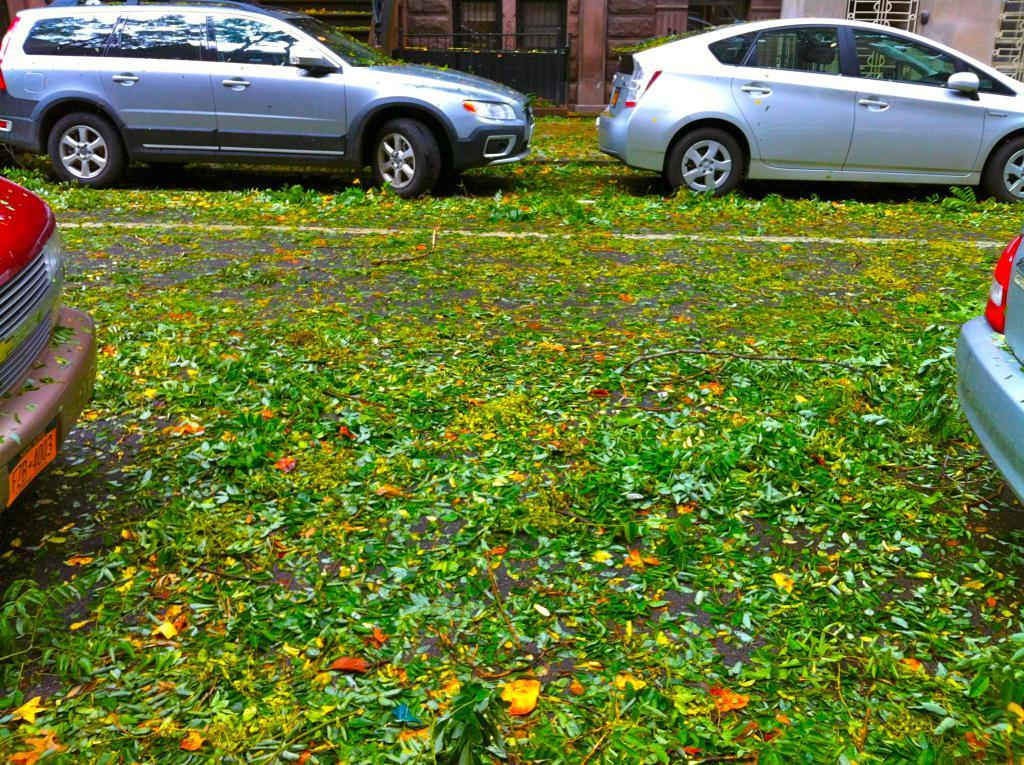What type of natural elements can be seen in the image? There are leaves in the image. What type of man-made objects can be seen in the image? There are cars on the road in the image. How many balloons are floating in the image? There are no balloons present in the image. What type of financial obligation is depicted in the image? There is no depiction of debt in the image. 